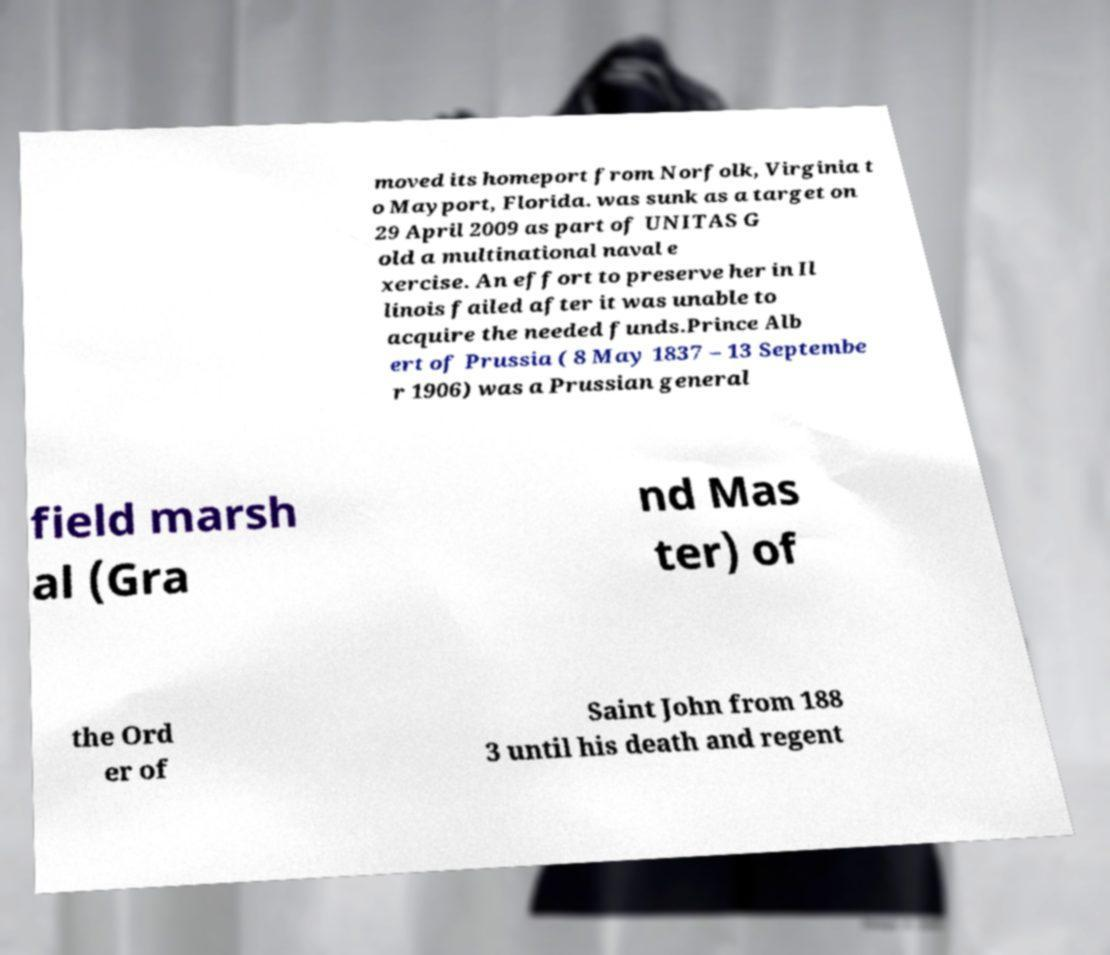For documentation purposes, I need the text within this image transcribed. Could you provide that? moved its homeport from Norfolk, Virginia t o Mayport, Florida. was sunk as a target on 29 April 2009 as part of UNITAS G old a multinational naval e xercise. An effort to preserve her in Il linois failed after it was unable to acquire the needed funds.Prince Alb ert of Prussia ( 8 May 1837 – 13 Septembe r 1906) was a Prussian general field marsh al (Gra nd Mas ter) of the Ord er of Saint John from 188 3 until his death and regent 